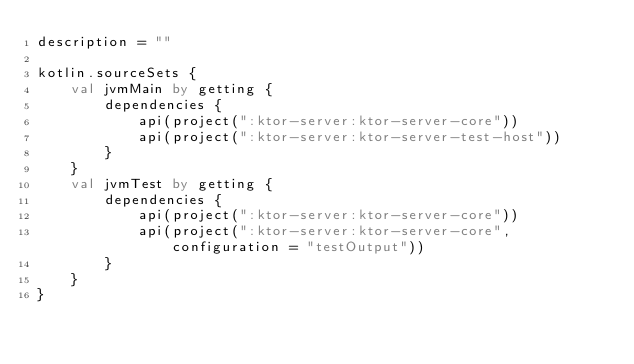<code> <loc_0><loc_0><loc_500><loc_500><_Kotlin_>description = ""

kotlin.sourceSets {
    val jvmMain by getting {
        dependencies {
            api(project(":ktor-server:ktor-server-core"))
            api(project(":ktor-server:ktor-server-test-host"))
        }
    }
    val jvmTest by getting {
        dependencies {
            api(project(":ktor-server:ktor-server-core"))
            api(project(":ktor-server:ktor-server-core", configuration = "testOutput"))
        }
    }
}
</code> 